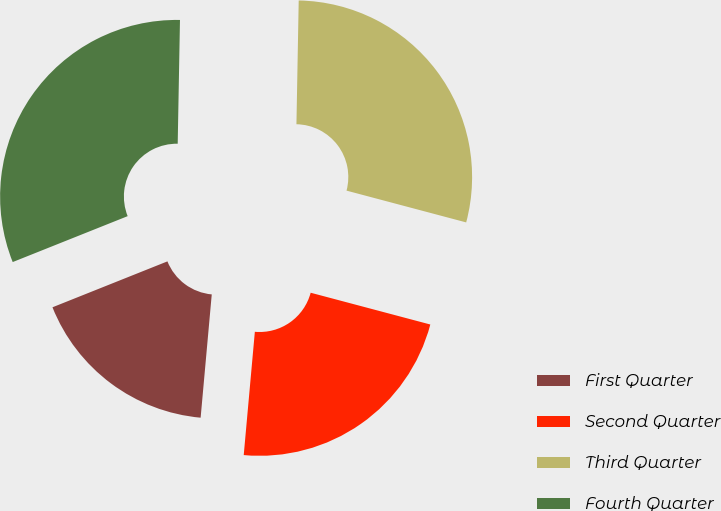Convert chart to OTSL. <chart><loc_0><loc_0><loc_500><loc_500><pie_chart><fcel>First Quarter<fcel>Second Quarter<fcel>Third Quarter<fcel>Fourth Quarter<nl><fcel>17.52%<fcel>22.3%<fcel>28.84%<fcel>31.34%<nl></chart> 